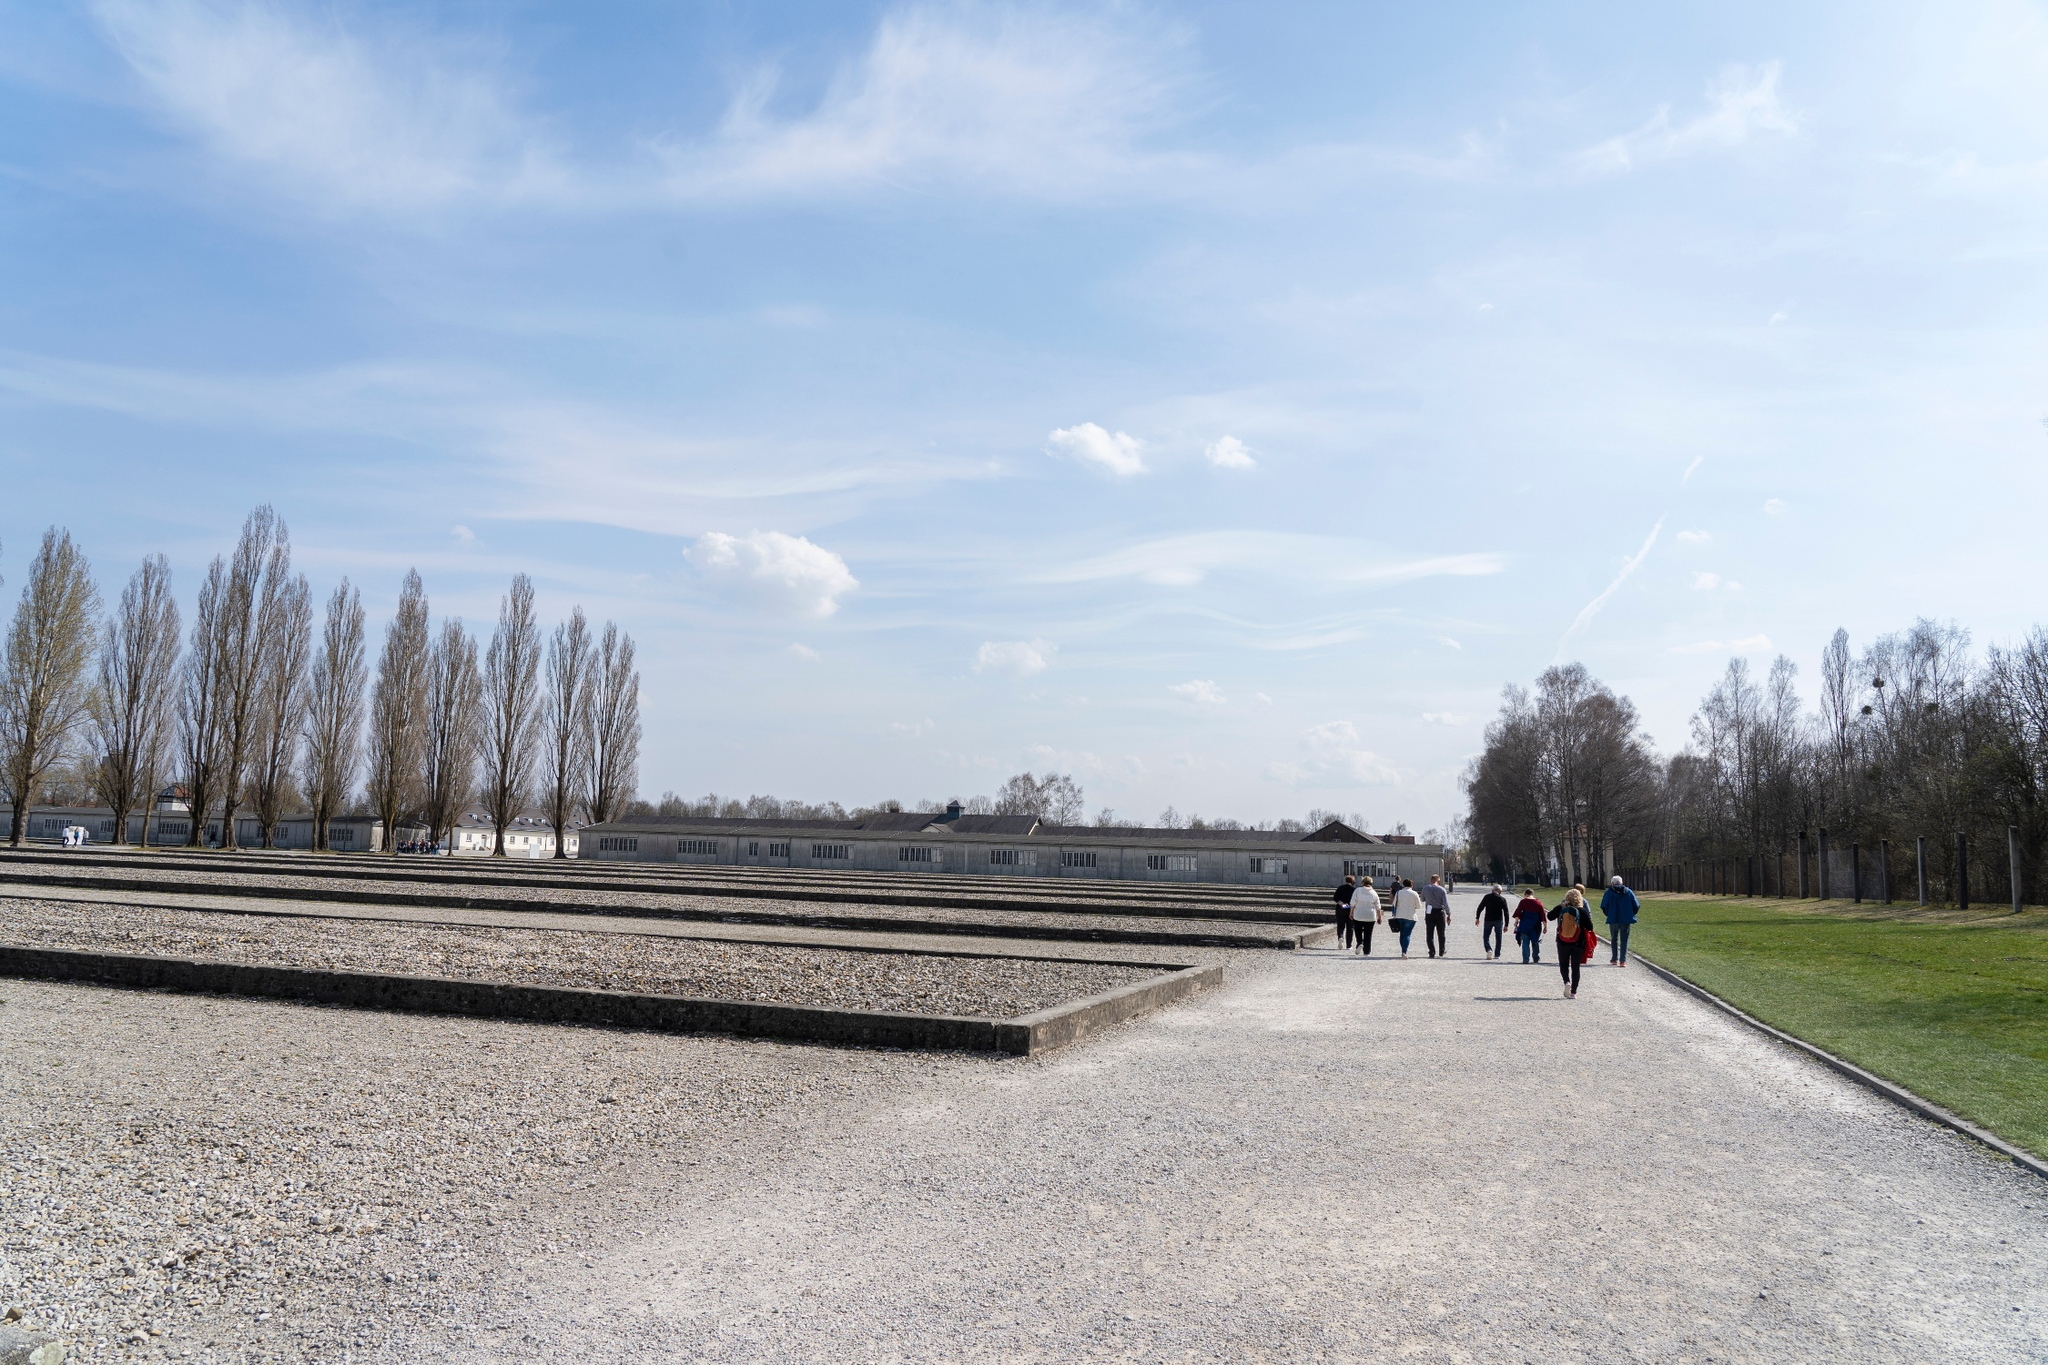Realistic Scenario: Describe a day in the life of a tour guide working at this memorial site. A day in the life of a tour guide at the Dachau Concentration Camp Memorial Site begins early. The guide arrives before the opening hours to prepare for the day, reviewing historical facts and checking the day’s tour schedule. They walk through the site, ensuring each section is ready to welcome visitors, from the barracks to the crematorium and the memorial sculptures. As visitors start arriving, the guide gathers groups at the entrance, welcoming them warmly and providing an overview of the day’s tour. Throughout the day, the guide recounts the harrowing stories with empathy and respect, answering questions and facilitating a deep understanding of the events that took place. They pause to allow visitors moments of reflection, sensing the solemnity and emotion that the space invokes. By the end of the day, after hours of walking and storytelling, the guide is tired but fulfilled, knowing they’ve played a key role in educating others and preserving the memory of the past. They finish with a quiet walk through the site, contemplating their own connection to the history they’ve spent the day recounting. 